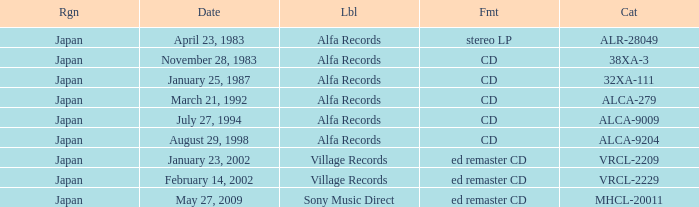Which region is identified as 38xa-3 in the catalog? Japan. Parse the full table. {'header': ['Rgn', 'Date', 'Lbl', 'Fmt', 'Cat'], 'rows': [['Japan', 'April 23, 1983', 'Alfa Records', 'stereo LP', 'ALR-28049'], ['Japan', 'November 28, 1983', 'Alfa Records', 'CD', '38XA-3'], ['Japan', 'January 25, 1987', 'Alfa Records', 'CD', '32XA-111'], ['Japan', 'March 21, 1992', 'Alfa Records', 'CD', 'ALCA-279'], ['Japan', 'July 27, 1994', 'Alfa Records', 'CD', 'ALCA-9009'], ['Japan', 'August 29, 1998', 'Alfa Records', 'CD', 'ALCA-9204'], ['Japan', 'January 23, 2002', 'Village Records', 'ed remaster CD', 'VRCL-2209'], ['Japan', 'February 14, 2002', 'Village Records', 'ed remaster CD', 'VRCL-2229'], ['Japan', 'May 27, 2009', 'Sony Music Direct', 'ed remaster CD', 'MHCL-20011']]} 